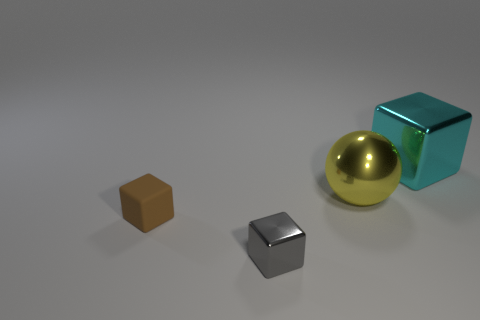What number of other objects are the same size as the yellow sphere?
Offer a terse response. 1. What color is the tiny metal cube?
Offer a very short reply. Gray. What number of matte objects are big red spheres or large yellow things?
Keep it short and to the point. 0. Is there anything else that is made of the same material as the brown object?
Provide a succinct answer. No. There is a metal block that is in front of the shiny block behind the big object left of the large cyan shiny block; what is its size?
Offer a terse response. Small. There is a cube that is both behind the gray block and in front of the yellow metallic object; what size is it?
Keep it short and to the point. Small. There is a tiny matte object; what number of big balls are in front of it?
Offer a terse response. 0. Are there any brown blocks in front of the shiny block to the right of the shiny block in front of the sphere?
Your answer should be very brief. Yes. What number of cyan things are the same size as the metallic ball?
Keep it short and to the point. 1. The big thing to the left of the metal block that is behind the gray object is made of what material?
Your answer should be compact. Metal. 